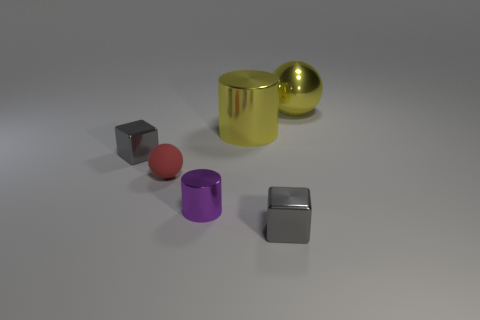Add 4 purple shiny cylinders. How many objects exist? 10 Subtract all balls. How many objects are left? 4 Add 4 large metal cylinders. How many large metal cylinders are left? 5 Add 1 big yellow shiny things. How many big yellow shiny things exist? 3 Subtract 0 brown blocks. How many objects are left? 6 Subtract all metallic things. Subtract all large cyan shiny cubes. How many objects are left? 1 